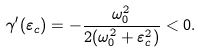Convert formula to latex. <formula><loc_0><loc_0><loc_500><loc_500>\gamma ^ { \prime } ( \varepsilon _ { c } ) = - \frac { \omega _ { 0 } ^ { 2 } } { 2 ( \omega _ { 0 } ^ { 2 } + \varepsilon _ { c } ^ { 2 } ) } < 0 .</formula> 